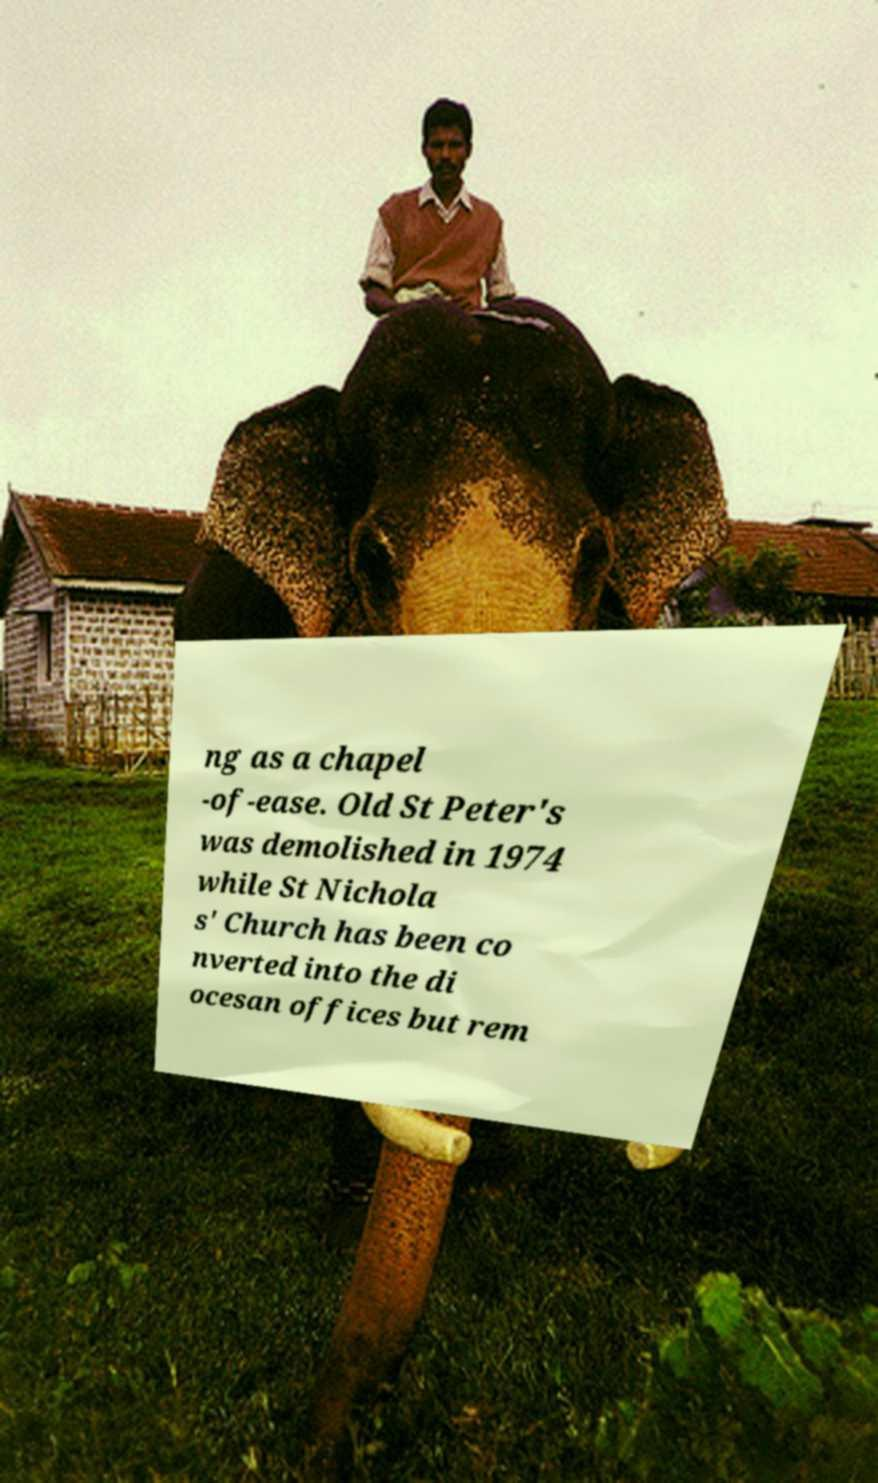Please read and relay the text visible in this image. What does it say? ng as a chapel -of-ease. Old St Peter's was demolished in 1974 while St Nichola s' Church has been co nverted into the di ocesan offices but rem 